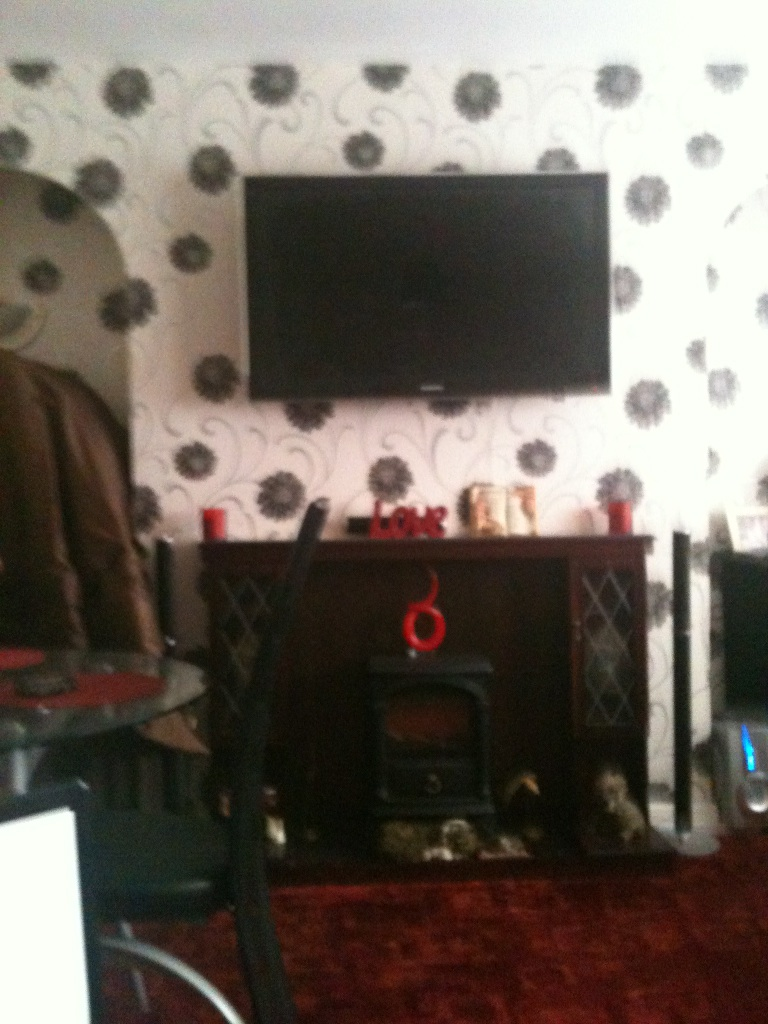Can you describe the overall decor style of this room? The decor style of this room appears to be a blend of modern and cozy elements. The wallpaper has a bold floral pattern in monochromatic tones, creating a stylish backdrop for the large flat-screen television mounted on the wall. The presence of a fireplace adds to the warmth and charm of the space, with little decorative items enhancing the homey feel. What can you infer about the lifestyle of the inhabitants based on this room? Based on the room's decor, it can be inferred that the inhabitants likely value a comfortable and relaxing living environment. The television mounted on the wall suggests they may enjoy watching TV or movies, possibly as a central activity during leisure time. The fireplace and decorative elements indicate a preference for a warm and inviting atmosphere, likely appreciating a blend of modern conveniences with a touch of traditional comfort. 